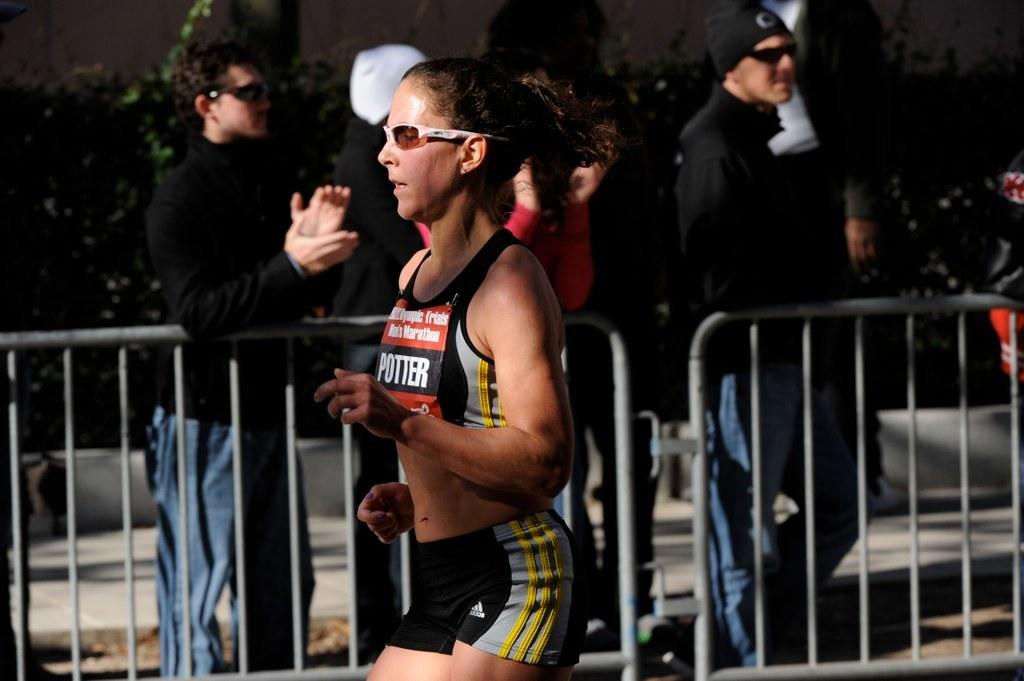<image>
Summarize the visual content of the image. runner with adidas shorts named potter running Olympic trials men's marathon 